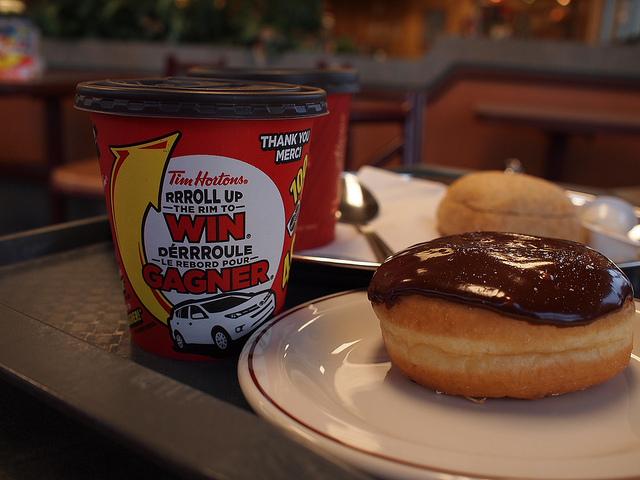What color is the frosting on the donut?
Give a very brief answer. Brown. Is that a doughnut?
Quick response, please. Yes. What logo is on the coffee cup?
Short answer required. Tim horton. Where was the donut purchased?
Answer briefly. Tim hortons. What color are the donuts?
Quick response, please. Brown. What is in the red cup?
Quick response, please. Coffee. Is there any chocolate in this photo?
Give a very brief answer. Yes. How many donuts are on the plate?
Quick response, please. 1. Which donut would you eat?
Give a very brief answer. Chocolate. What is on top of the doughnut?
Quick response, please. Chocolate. What kind of silverware is shown?
Keep it brief. Spoon. Has the doughnut been partially eaten?
Write a very short answer. No. What day is it for Neil?
Be succinct. Monday. Where did the beverage come from?
Write a very short answer. Tim hortons. 